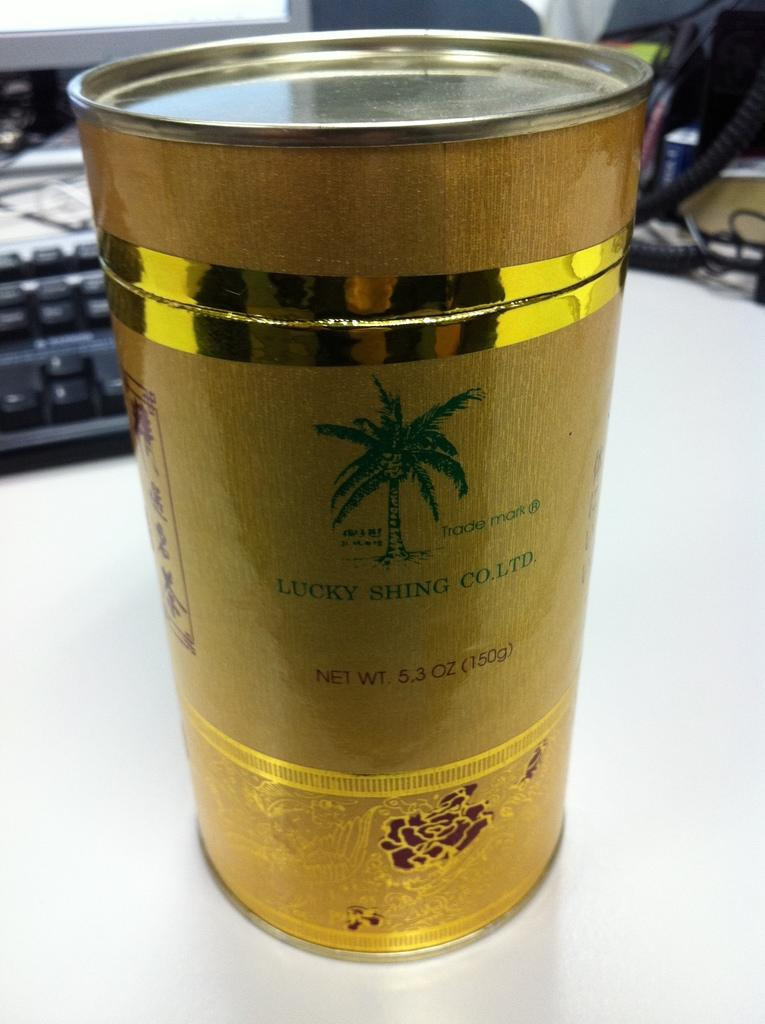<image>
Summarize the visual content of the image. A can from the Lucky Shing Co. contains 150 grams of product. 